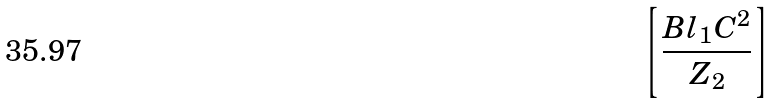Convert formula to latex. <formula><loc_0><loc_0><loc_500><loc_500>\left [ \frac { B l _ { 1 } { C } ^ { 2 } } { { Z } _ { 2 } } \right ]</formula> 